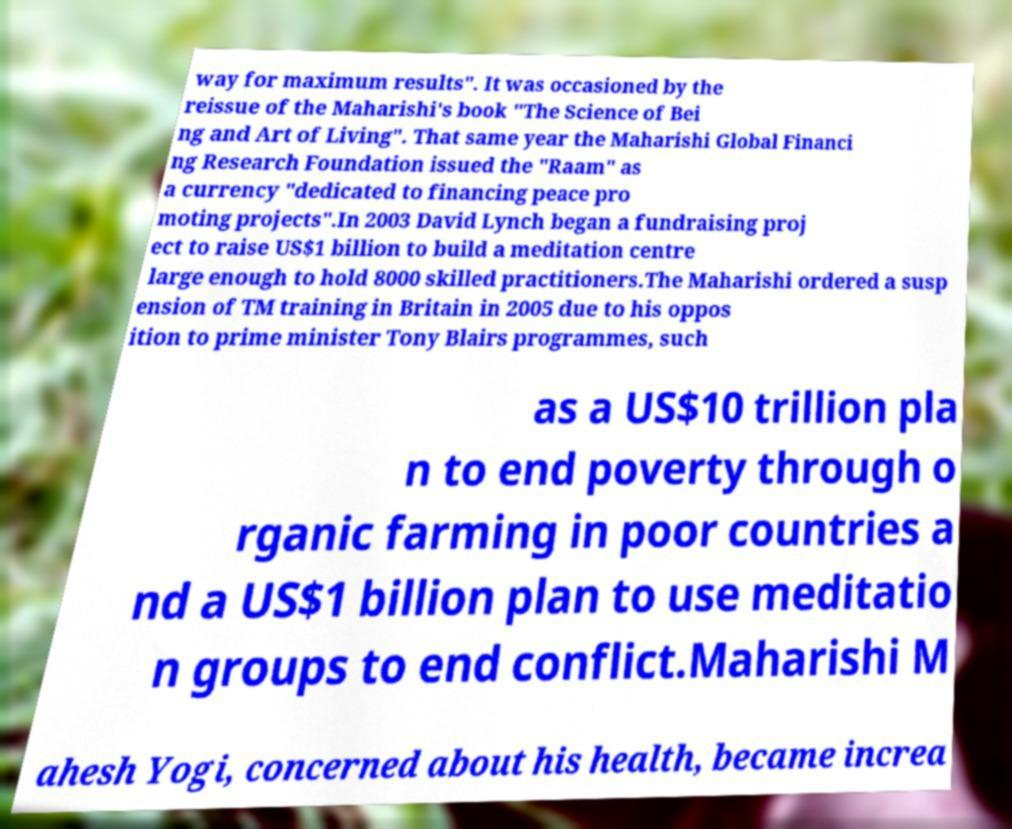I need the written content from this picture converted into text. Can you do that? way for maximum results". It was occasioned by the reissue of the Maharishi's book "The Science of Bei ng and Art of Living". That same year the Maharishi Global Financi ng Research Foundation issued the "Raam" as a currency "dedicated to financing peace pro moting projects".In 2003 David Lynch began a fundraising proj ect to raise US$1 billion to build a meditation centre large enough to hold 8000 skilled practitioners.The Maharishi ordered a susp ension of TM training in Britain in 2005 due to his oppos ition to prime minister Tony Blairs programmes, such as a US$10 trillion pla n to end poverty through o rganic farming in poor countries a nd a US$1 billion plan to use meditatio n groups to end conflict.Maharishi M ahesh Yogi, concerned about his health, became increa 